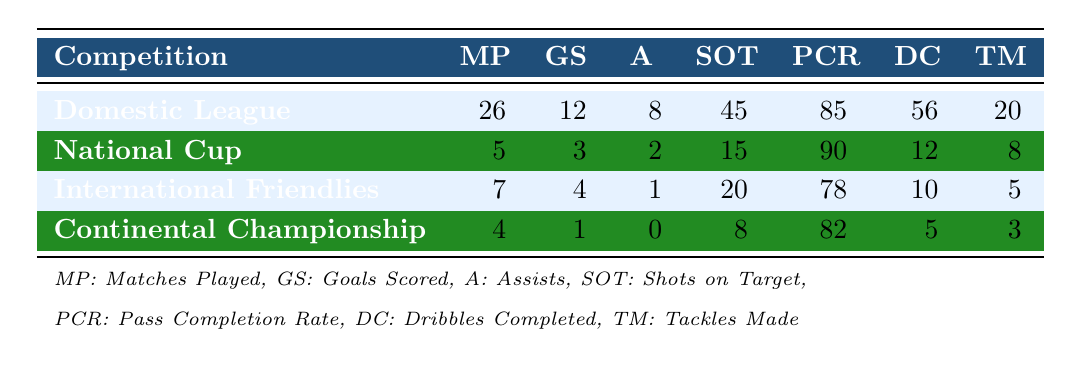What is the total number of Matches Played by Mohammad Moradi across all competitions? The number of Matches Played in each competition are: 26 (Domestic League) + 5 (National Cup) + 7 (International Friendlies) + 4 (Continental Championship) = 42.
Answer: 42 What is the highest Goals Scored by Mohammad Moradi in a single competition? The Goals Scored in each competition are: 12 (Domestic League), 3 (National Cup), 4 (International Friendlies), and 1 (Continental Championship). The highest among these is 12.
Answer: 12 Did Mohammad Moradi have more Assists in the Domestic League or in the National Cup? The Assists in the Domestic League is 8 while in the National Cup it is 2. Since 8 > 2, he had more Assists in the Domestic League.
Answer: Yes What is the average Shots on Target Mohammad Moradi achieved in the International Friendlies and Continental Championship? The Shots on Target for both competitions are: 20 (International Friendlies) and 8 (Continental Championship). To find the average, we sum them up (20 + 8 = 28) and divide by 2, giving us an average of 14.
Answer: 14 Did Mohammad Moradi achieve a better Pass Completion Rate in the National Cup compared to the Domestic League? The Pass Completion Rates are 90% for the National Cup and 85% for the Domestic League. Since 90% > 85%, he did achieve a better Pass Completion Rate in the National Cup.
Answer: Yes How many more Dribbles Completed did Moradi have in the Domestic League compared to the Continental Championship? The Dribbles Completed are 56 (Domestic League) and 5 (Continental Championship). The difference is 56 - 5 = 51.
Answer: 51 What is the total number of Tackles Made by Mohammad Moradi in all competitions? The number of Tackles Made in each competition are: 20 (Domestic League) + 8 (National Cup) + 5 (International Friendlies) + 3 (Continental Championship) = 36.
Answer: 36 In which competition did Mohammad Moradi have the lowest Pass Completion Rate? The Pass Completion Rates for each competition are: 85% (Domestic League), 90% (National Cup), 78% (International Friendlies), and 82% (Continental Championship). The lowest rate is 78% in International Friendlies.
Answer: International Friendlies What percentage of the total Matches Played resulted in Goals Scored for Mohammad Moradi? He scored a total of 12 + 3 + 4 + 1 = 20 Goals across 42 Matches. The percentage of matches that resulted in Goals is (20/42)*100 ≈ 47.62%.
Answer: Approximately 47.62% 